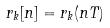<formula> <loc_0><loc_0><loc_500><loc_500>r _ { k } [ n ] = r _ { k } ( n T )</formula> 